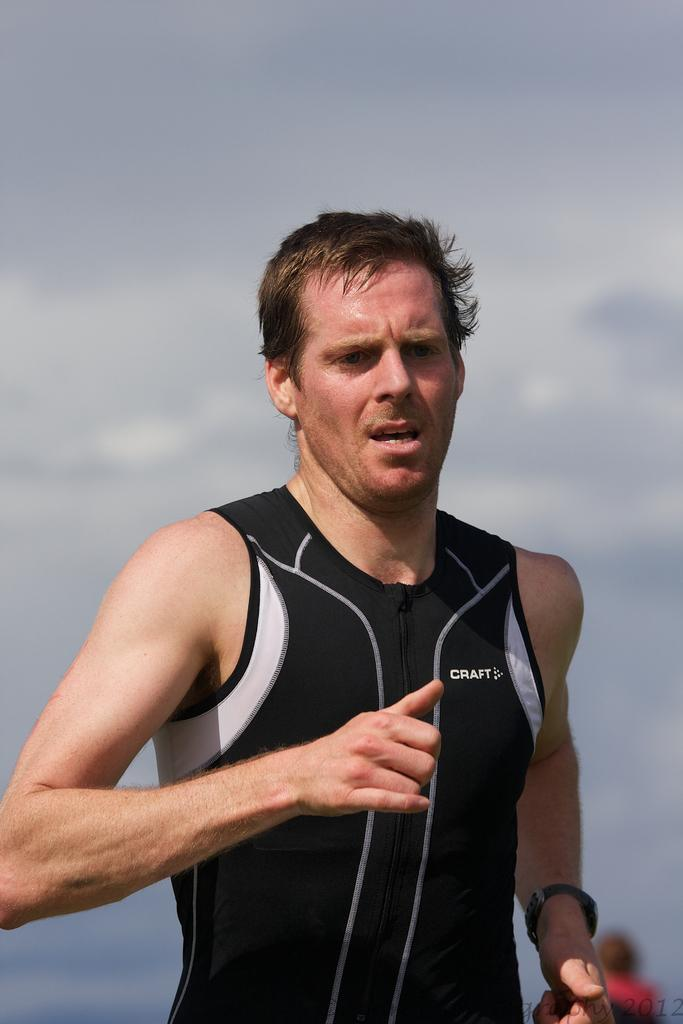<image>
Write a terse but informative summary of the picture. A man running with a shirt with a brand called Craft 